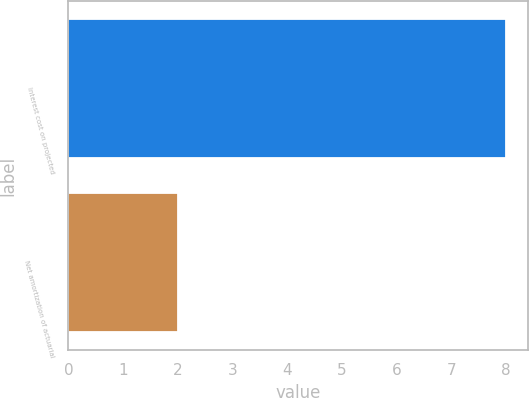Convert chart. <chart><loc_0><loc_0><loc_500><loc_500><bar_chart><fcel>Interest cost on projected<fcel>Net amortization of actuarial<nl><fcel>8<fcel>2<nl></chart> 